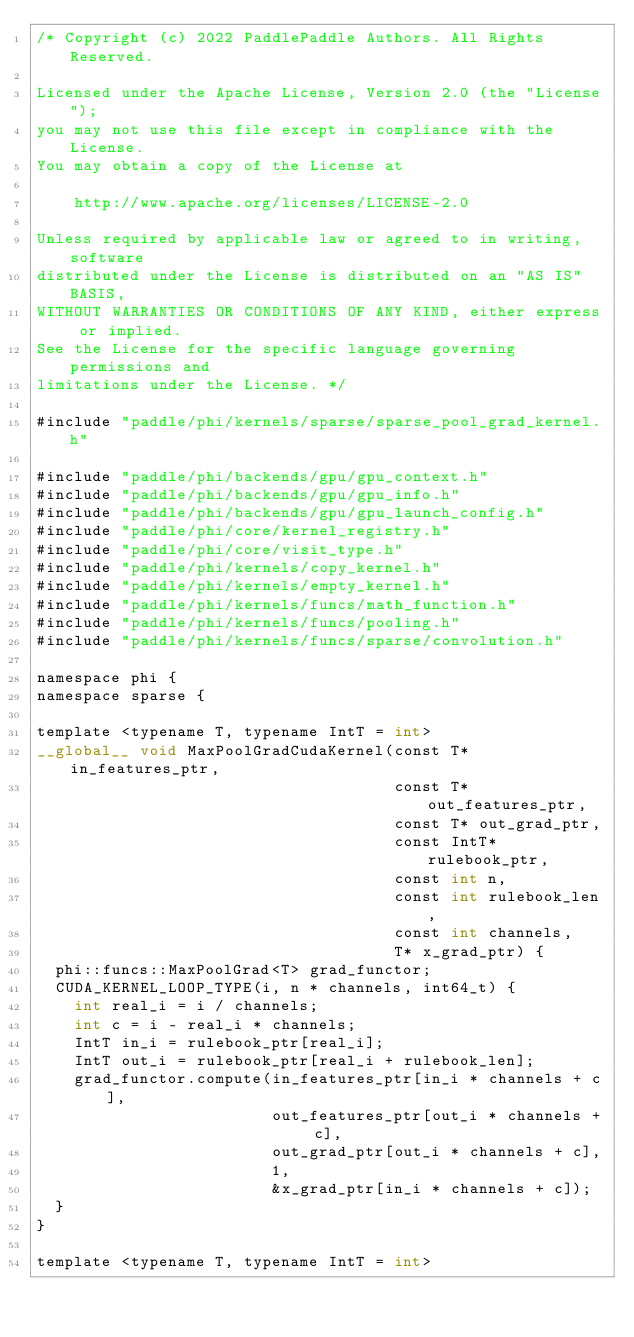Convert code to text. <code><loc_0><loc_0><loc_500><loc_500><_Cuda_>/* Copyright (c) 2022 PaddlePaddle Authors. All Rights Reserved.

Licensed under the Apache License, Version 2.0 (the "License");
you may not use this file except in compliance with the License.
You may obtain a copy of the License at

    http://www.apache.org/licenses/LICENSE-2.0

Unless required by applicable law or agreed to in writing, software
distributed under the License is distributed on an "AS IS" BASIS,
WITHOUT WARRANTIES OR CONDITIONS OF ANY KIND, either express or implied.
See the License for the specific language governing permissions and
limitations under the License. */

#include "paddle/phi/kernels/sparse/sparse_pool_grad_kernel.h"

#include "paddle/phi/backends/gpu/gpu_context.h"
#include "paddle/phi/backends/gpu/gpu_info.h"
#include "paddle/phi/backends/gpu/gpu_launch_config.h"
#include "paddle/phi/core/kernel_registry.h"
#include "paddle/phi/core/visit_type.h"
#include "paddle/phi/kernels/copy_kernel.h"
#include "paddle/phi/kernels/empty_kernel.h"
#include "paddle/phi/kernels/funcs/math_function.h"
#include "paddle/phi/kernels/funcs/pooling.h"
#include "paddle/phi/kernels/funcs/sparse/convolution.h"

namespace phi {
namespace sparse {

template <typename T, typename IntT = int>
__global__ void MaxPoolGradCudaKernel(const T* in_features_ptr,
                                      const T* out_features_ptr,
                                      const T* out_grad_ptr,
                                      const IntT* rulebook_ptr,
                                      const int n,
                                      const int rulebook_len,
                                      const int channels,
                                      T* x_grad_ptr) {
  phi::funcs::MaxPoolGrad<T> grad_functor;
  CUDA_KERNEL_LOOP_TYPE(i, n * channels, int64_t) {
    int real_i = i / channels;
    int c = i - real_i * channels;
    IntT in_i = rulebook_ptr[real_i];
    IntT out_i = rulebook_ptr[real_i + rulebook_len];
    grad_functor.compute(in_features_ptr[in_i * channels + c],
                         out_features_ptr[out_i * channels + c],
                         out_grad_ptr[out_i * channels + c],
                         1,
                         &x_grad_ptr[in_i * channels + c]);
  }
}

template <typename T, typename IntT = int></code> 